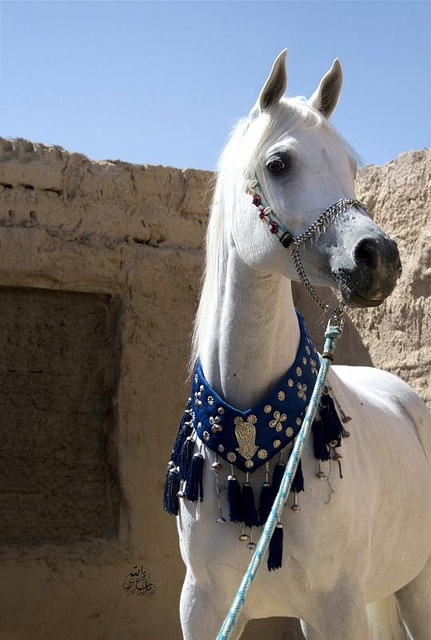Describe the objects in this image and their specific colors. I can see a horse in lightblue, darkgray, gray, and black tones in this image. 